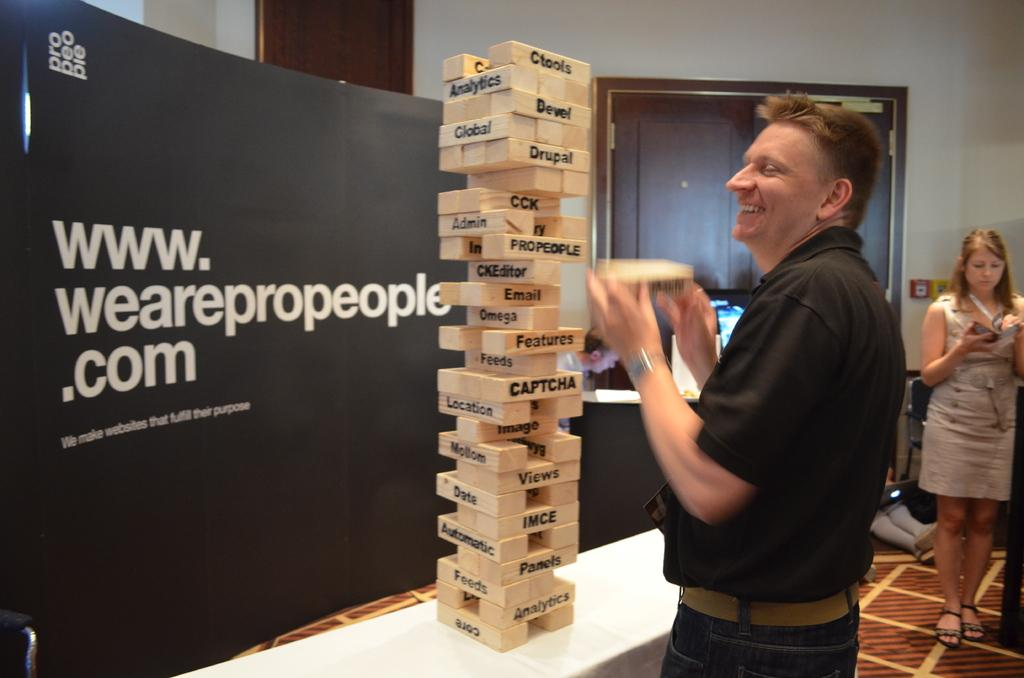<image>
Offer a succinct explanation of the picture presented. A man builds a giant Jenga tower sponsored by a company called Pro People 